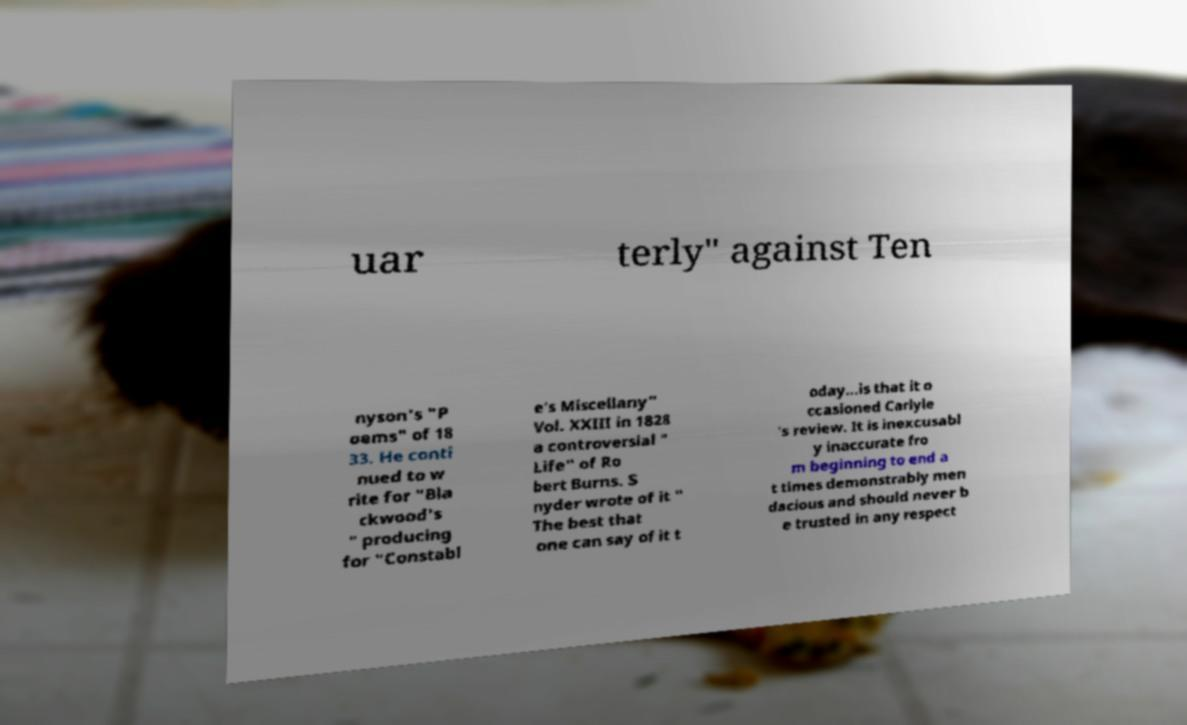Could you extract and type out the text from this image? uar terly" against Ten nyson's "P oems" of 18 33. He conti nued to w rite for "Bla ckwood's " producing for "Constabl e's Miscellany" Vol. XXIII in 1828 a controversial " Life" of Ro bert Burns. S nyder wrote of it " The best that one can say of it t oday...is that it o ccasioned Carlyle 's review. It is inexcusabl y inaccurate fro m beginning to end a t times demonstrably men dacious and should never b e trusted in any respect 